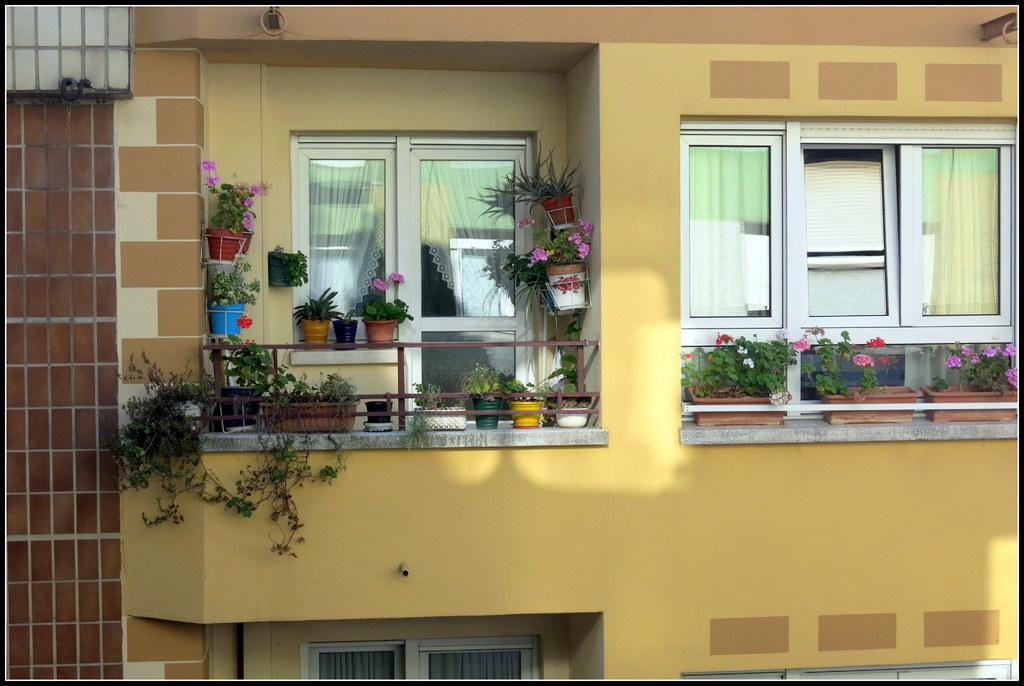What type of plants are visible in the image? There are flower plants in the image. What material are the windows made of in the image? The windows in the image are made of glass. Can you describe the setting of the image? The setting appears to be an outside part of a building. What flavor of pie is being served at the company event in the image? There is no company event or pie present in the image; it features flower plants and glass windows in an outside part of a building. 